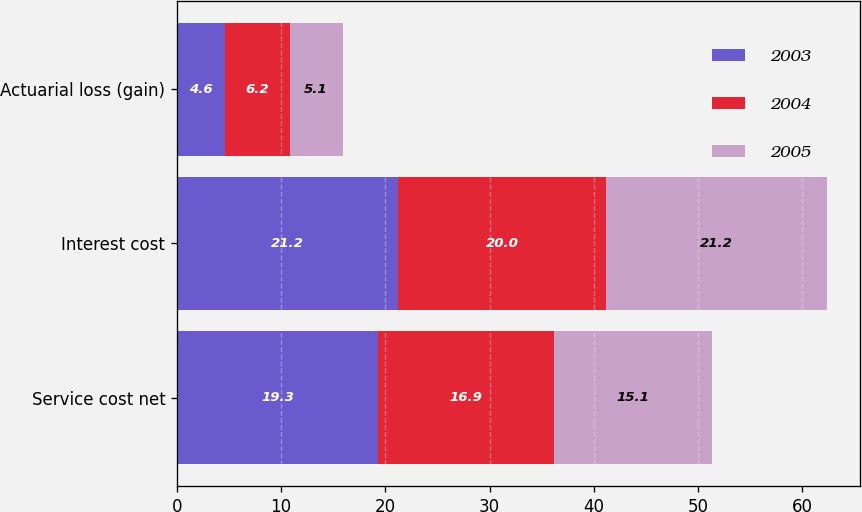Convert chart to OTSL. <chart><loc_0><loc_0><loc_500><loc_500><stacked_bar_chart><ecel><fcel>Service cost net<fcel>Interest cost<fcel>Actuarial loss (gain)<nl><fcel>2003<fcel>19.3<fcel>21.2<fcel>4.6<nl><fcel>2004<fcel>16.9<fcel>20<fcel>6.2<nl><fcel>2005<fcel>15.1<fcel>21.2<fcel>5.1<nl></chart> 